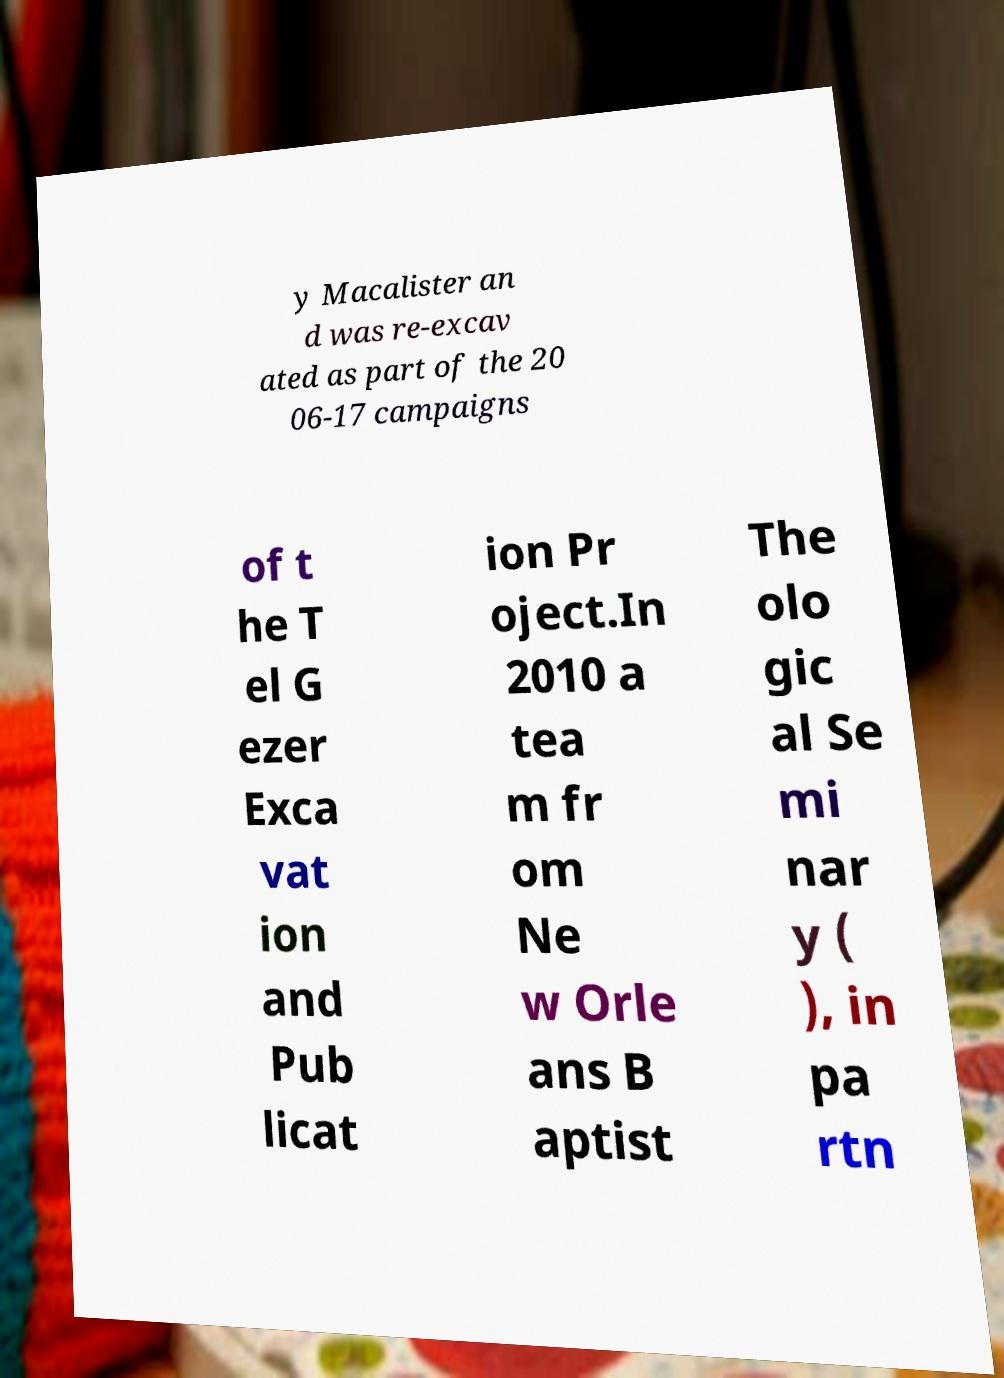For documentation purposes, I need the text within this image transcribed. Could you provide that? y Macalister an d was re-excav ated as part of the 20 06-17 campaigns of t he T el G ezer Exca vat ion and Pub licat ion Pr oject.In 2010 a tea m fr om Ne w Orle ans B aptist The olo gic al Se mi nar y ( ), in pa rtn 